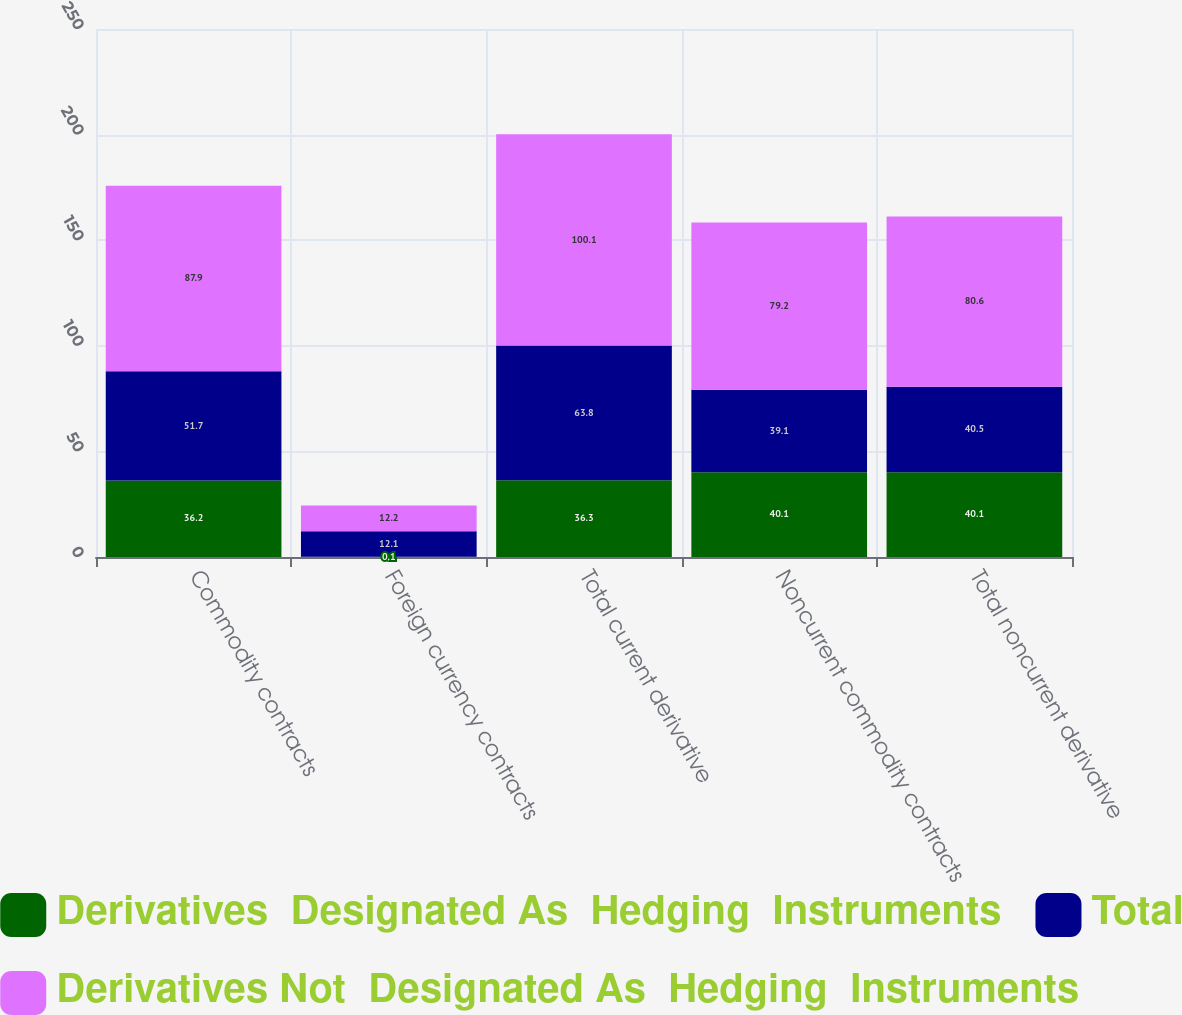<chart> <loc_0><loc_0><loc_500><loc_500><stacked_bar_chart><ecel><fcel>Commodity contracts<fcel>Foreign currency contracts<fcel>Total current derivative<fcel>Noncurrent commodity contracts<fcel>Total noncurrent derivative<nl><fcel>Derivatives  Designated As  Hedging  Instruments<fcel>36.2<fcel>0.1<fcel>36.3<fcel>40.1<fcel>40.1<nl><fcel>Total<fcel>51.7<fcel>12.1<fcel>63.8<fcel>39.1<fcel>40.5<nl><fcel>Derivatives Not  Designated As  Hedging  Instruments<fcel>87.9<fcel>12.2<fcel>100.1<fcel>79.2<fcel>80.6<nl></chart> 